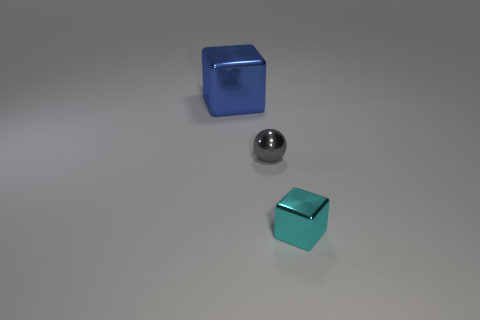The other metal thing that is the same shape as the blue object is what color?
Offer a terse response. Cyan. There is a metallic thing that is both to the left of the small cyan shiny block and on the right side of the big object; how big is it?
Give a very brief answer. Small. What number of gray metal spheres are in front of the metallic thing that is on the left side of the gray metallic thing behind the small cyan thing?
Keep it short and to the point. 1. How many big things are either yellow metallic cylinders or cyan cubes?
Give a very brief answer. 0. Does the cube that is on the left side of the small shiny block have the same material as the cyan thing?
Your response must be concise. Yes. What is the cube that is in front of the thing that is on the left side of the tiny metal object that is behind the small cyan metal object made of?
Ensure brevity in your answer.  Metal. Is there any other thing that is the same size as the blue object?
Keep it short and to the point. No. How many rubber things are big cyan cubes or large blue blocks?
Keep it short and to the point. 0. Are there any blue objects?
Ensure brevity in your answer.  Yes. What is the color of the sphere to the left of the shiny object that is right of the gray shiny sphere?
Your answer should be compact. Gray. 